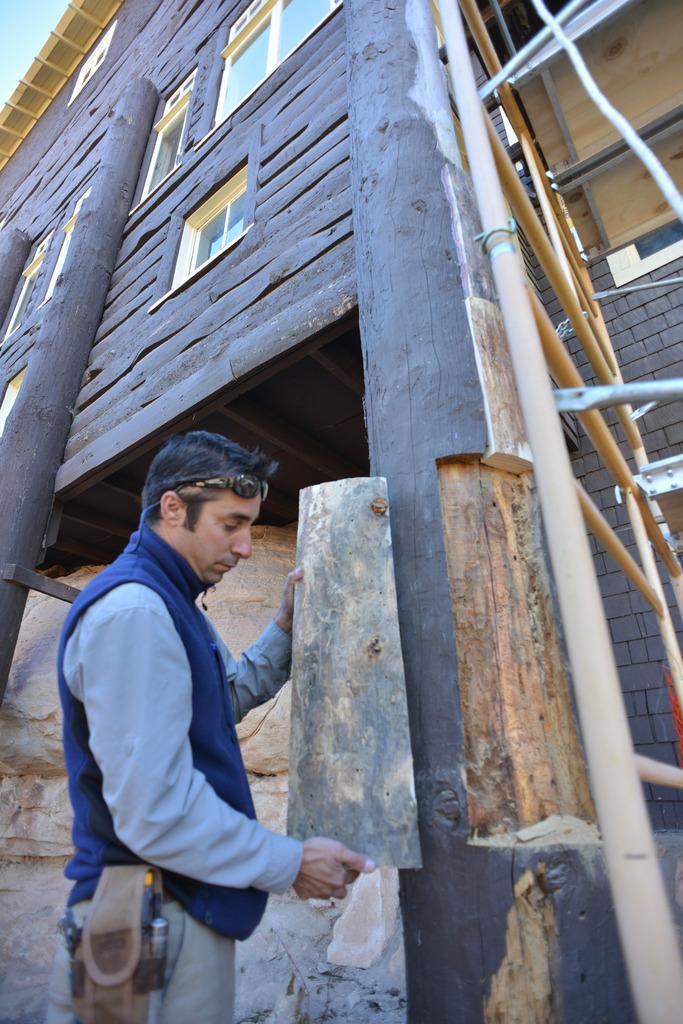Can you describe this image briefly? This is the man standing and holding a wooden object. This looks like a wooden house with windows. This looks like a ladder. These are the wooden pillars. I think this is the rock. 